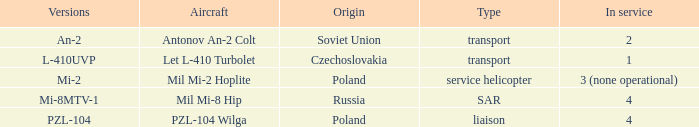Tell me the versions for czechoslovakia? L-410UVP. 